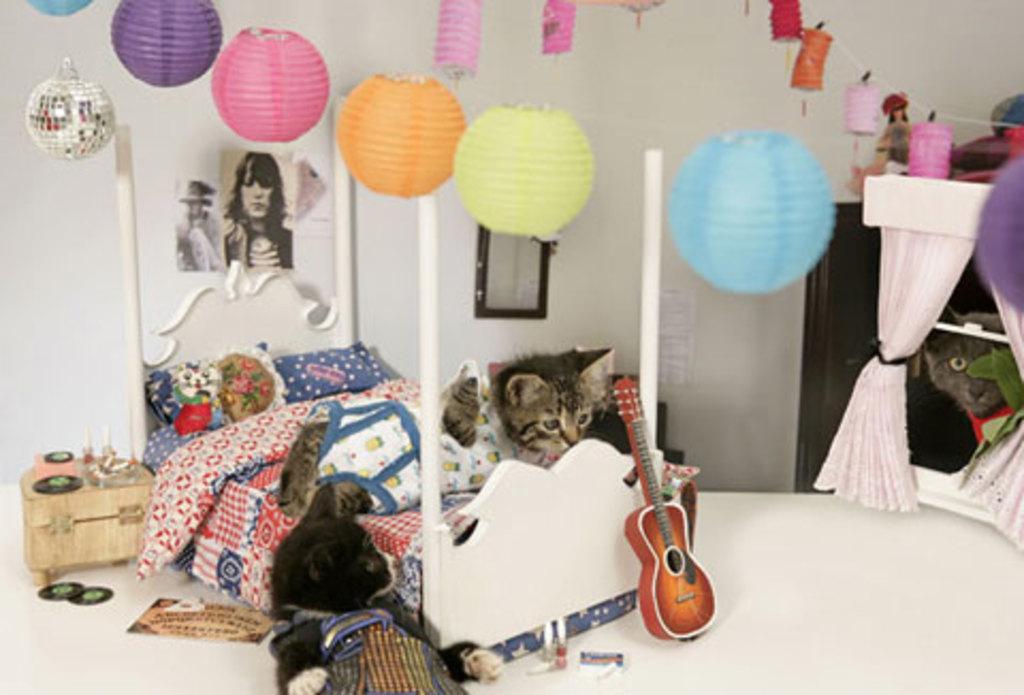In one or two sentences, can you explain what this image depicts? In this picture we can see a room with bed with bed sheet pillows on it and aside to this we have a cat, guitar and in background we can see wall with frames, balloons, curtains to racks, door. 